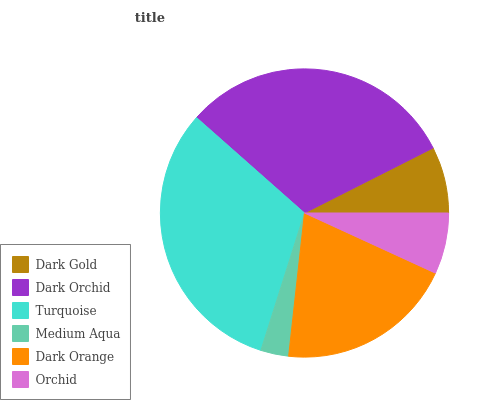Is Medium Aqua the minimum?
Answer yes or no. Yes. Is Turquoise the maximum?
Answer yes or no. Yes. Is Dark Orchid the minimum?
Answer yes or no. No. Is Dark Orchid the maximum?
Answer yes or no. No. Is Dark Orchid greater than Dark Gold?
Answer yes or no. Yes. Is Dark Gold less than Dark Orchid?
Answer yes or no. Yes. Is Dark Gold greater than Dark Orchid?
Answer yes or no. No. Is Dark Orchid less than Dark Gold?
Answer yes or no. No. Is Dark Orange the high median?
Answer yes or no. Yes. Is Dark Gold the low median?
Answer yes or no. Yes. Is Dark Gold the high median?
Answer yes or no. No. Is Orchid the low median?
Answer yes or no. No. 